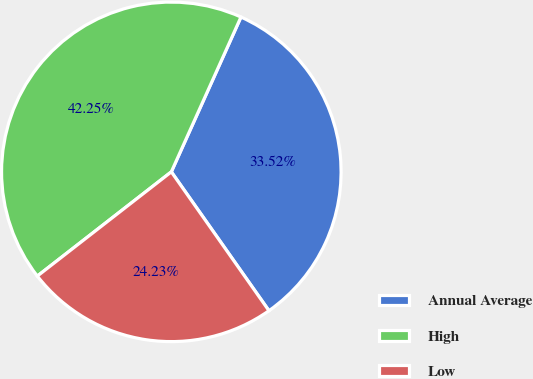Convert chart to OTSL. <chart><loc_0><loc_0><loc_500><loc_500><pie_chart><fcel>Annual Average<fcel>High<fcel>Low<nl><fcel>33.52%<fcel>42.25%<fcel>24.23%<nl></chart> 